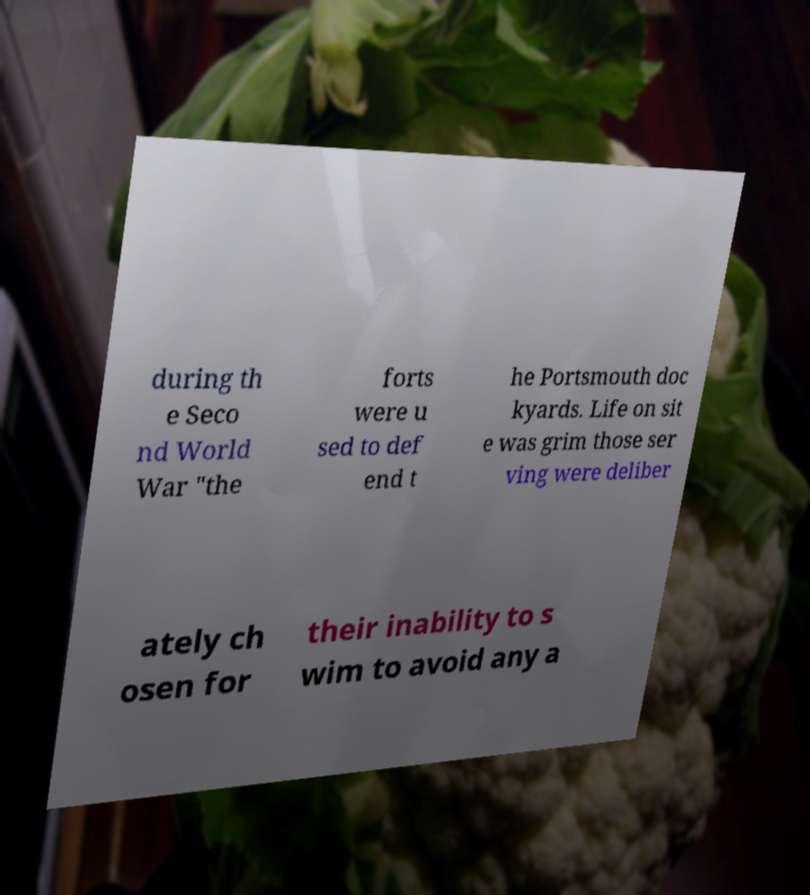I need the written content from this picture converted into text. Can you do that? during th e Seco nd World War "the forts were u sed to def end t he Portsmouth doc kyards. Life on sit e was grim those ser ving were deliber ately ch osen for their inability to s wim to avoid any a 